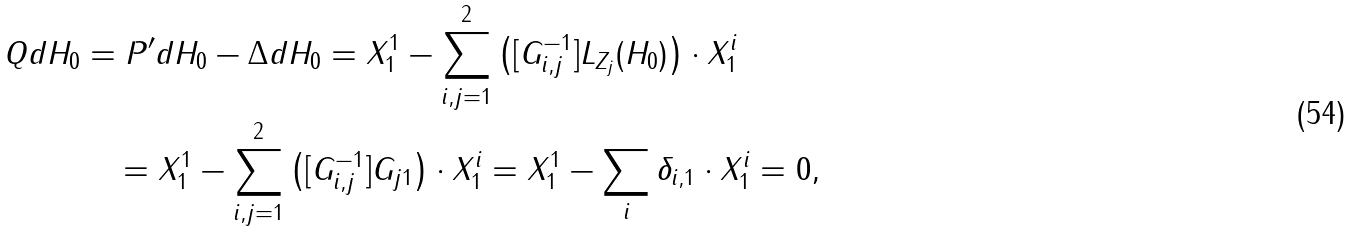<formula> <loc_0><loc_0><loc_500><loc_500>Q d H _ { 0 } & = P ^ { \prime } d H _ { 0 } - \Delta d H _ { 0 } = X ^ { 1 } _ { 1 } - \sum _ { i , j = 1 } ^ { 2 } \left ( [ { G } ^ { - 1 } _ { i , j } ] L _ { Z _ { j } } ( H _ { 0 } ) \right ) \cdot X _ { 1 } ^ { i } \\ & \quad = X ^ { 1 } _ { 1 } - \sum _ { i , j = 1 } ^ { 2 } \left ( [ { G } ^ { - 1 } _ { i , j } ] { G } _ { j 1 } \right ) \cdot X _ { 1 } ^ { i } = X _ { 1 } ^ { 1 } - \sum _ { i } \delta _ { i , 1 } \cdot X _ { 1 } ^ { i } = 0 ,</formula> 